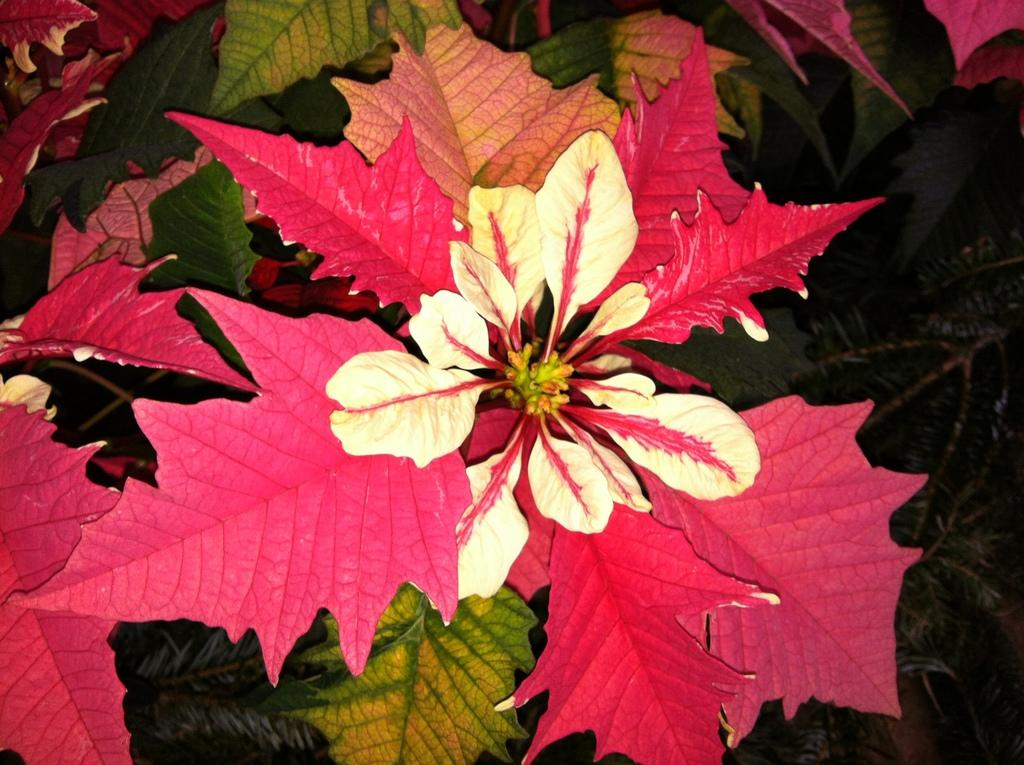What type of living organisms can be seen in the image? Plants can be seen in the image. What type of brass instrument is being played by the bean in the image? There is no brass instrument or bean present in the image; it only features plants. 